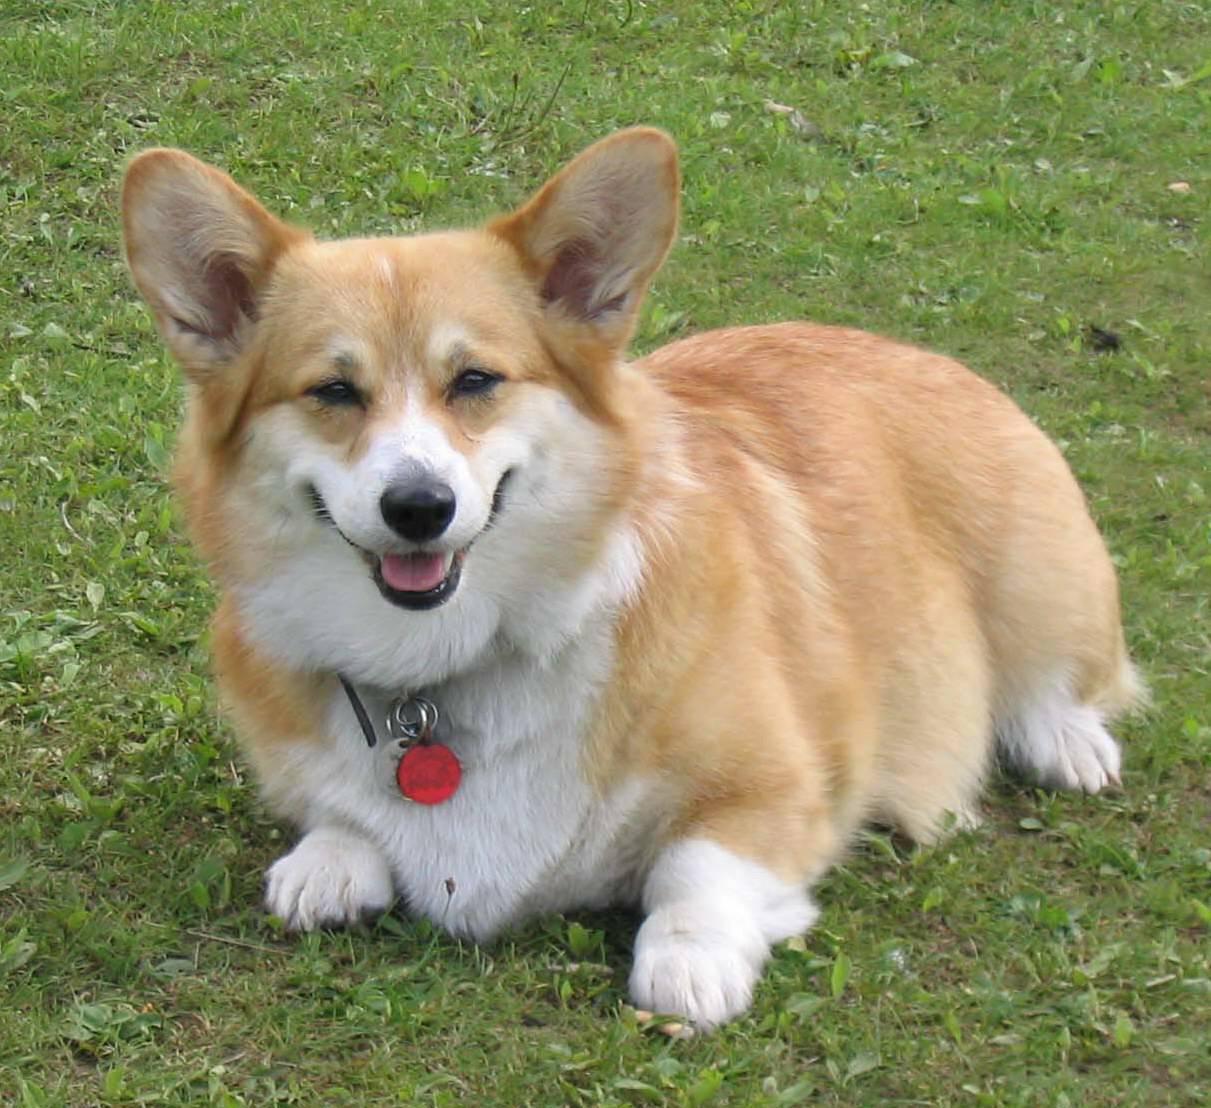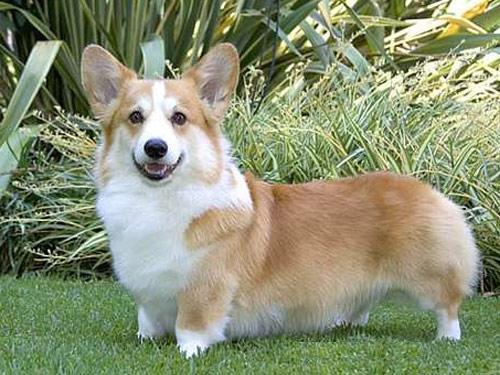The first image is the image on the left, the second image is the image on the right. Evaluate the accuracy of this statement regarding the images: "Left image shows a corgi dog standing with body turned rightward.". Is it true? Answer yes or no. No. The first image is the image on the left, the second image is the image on the right. Analyze the images presented: Is the assertion "The dog in the image on the left is facing right" valid? Answer yes or no. No. 